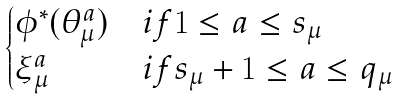Convert formula to latex. <formula><loc_0><loc_0><loc_500><loc_500>\begin{cases} \phi ^ { * } ( \theta _ { \mu } ^ { a } ) & i f 1 \leq a \leq s _ { \mu } \\ \xi _ { \mu } ^ { a } & i f s _ { \mu } + 1 \leq a \leq q _ { \mu } \end{cases}</formula> 